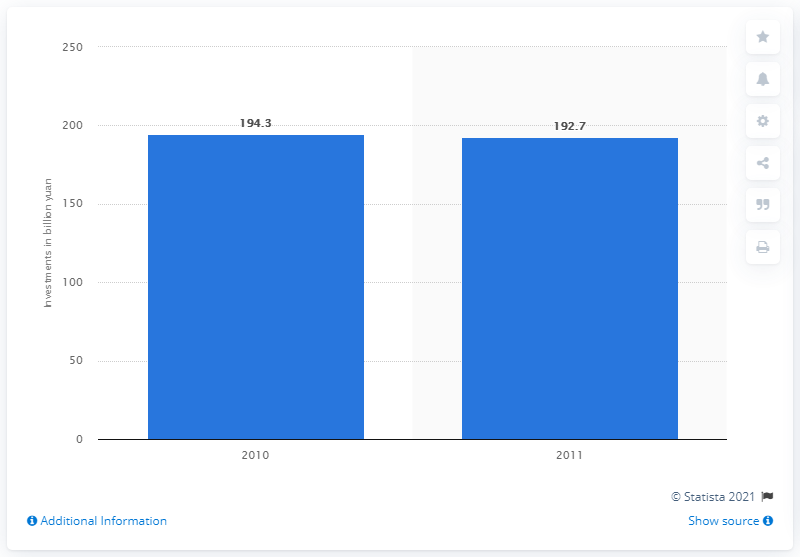List a handful of essential elements in this visual. In 2010, China invested a significant amount in shipping, with a specific amount of 192.7. 